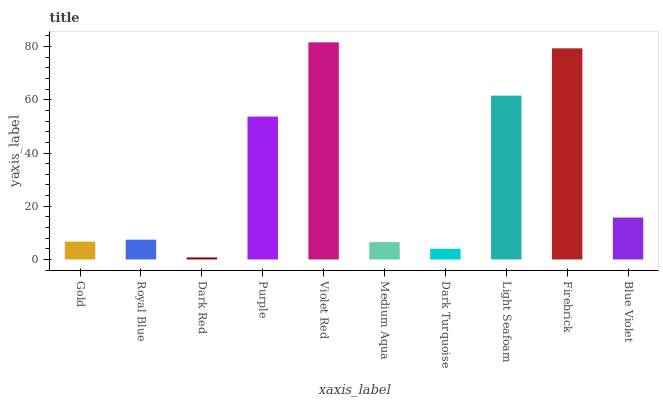Is Dark Red the minimum?
Answer yes or no. Yes. Is Violet Red the maximum?
Answer yes or no. Yes. Is Royal Blue the minimum?
Answer yes or no. No. Is Royal Blue the maximum?
Answer yes or no. No. Is Royal Blue greater than Gold?
Answer yes or no. Yes. Is Gold less than Royal Blue?
Answer yes or no. Yes. Is Gold greater than Royal Blue?
Answer yes or no. No. Is Royal Blue less than Gold?
Answer yes or no. No. Is Blue Violet the high median?
Answer yes or no. Yes. Is Royal Blue the low median?
Answer yes or no. Yes. Is Dark Red the high median?
Answer yes or no. No. Is Gold the low median?
Answer yes or no. No. 